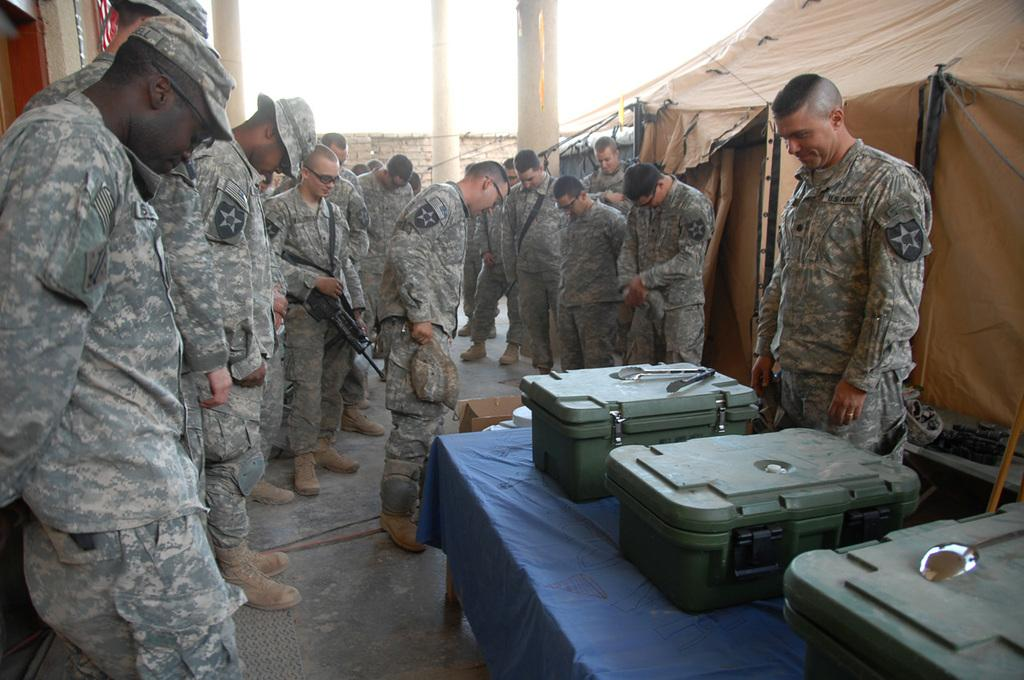What is the main subject of the image? The main subject of the image is a group of officers standing together. Where are the officers located in relation to other objects in the image? The officers are beside tents in the image. What other objects can be seen in the image? There is a table in the image. What is on the table? There are boxes on the table. Can you tell me how the officers are enjoying their pleasure in the image? There is no indication of pleasure or any activity related to pleasure in the image; the officers are simply standing in a group. 